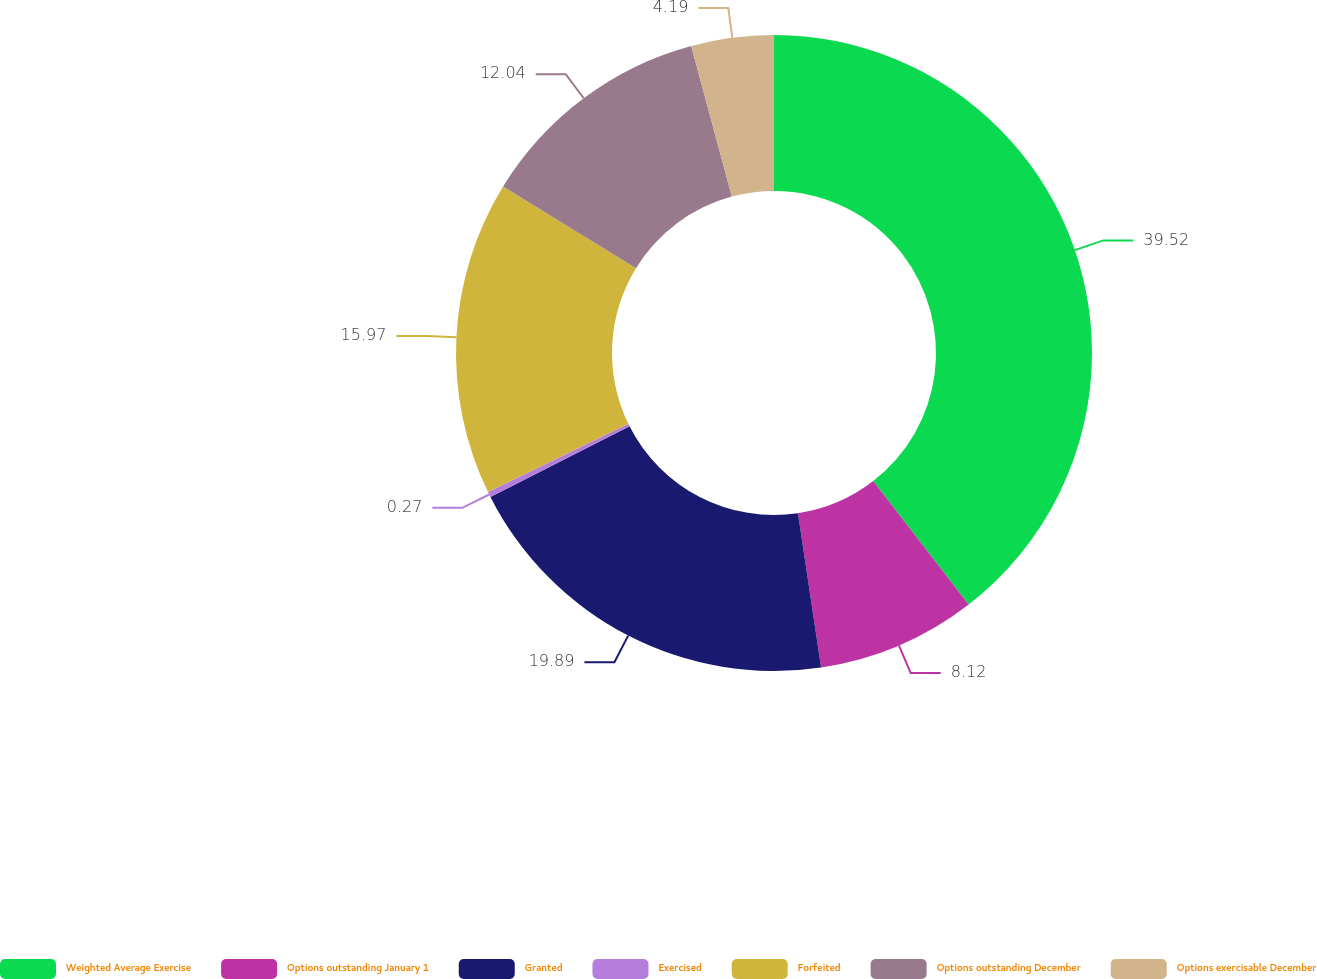Convert chart to OTSL. <chart><loc_0><loc_0><loc_500><loc_500><pie_chart><fcel>Weighted Average Exercise<fcel>Options outstanding January 1<fcel>Granted<fcel>Exercised<fcel>Forfeited<fcel>Options outstanding December<fcel>Options exercisable December<nl><fcel>39.51%<fcel>8.12%<fcel>19.89%<fcel>0.27%<fcel>15.97%<fcel>12.04%<fcel>4.19%<nl></chart> 